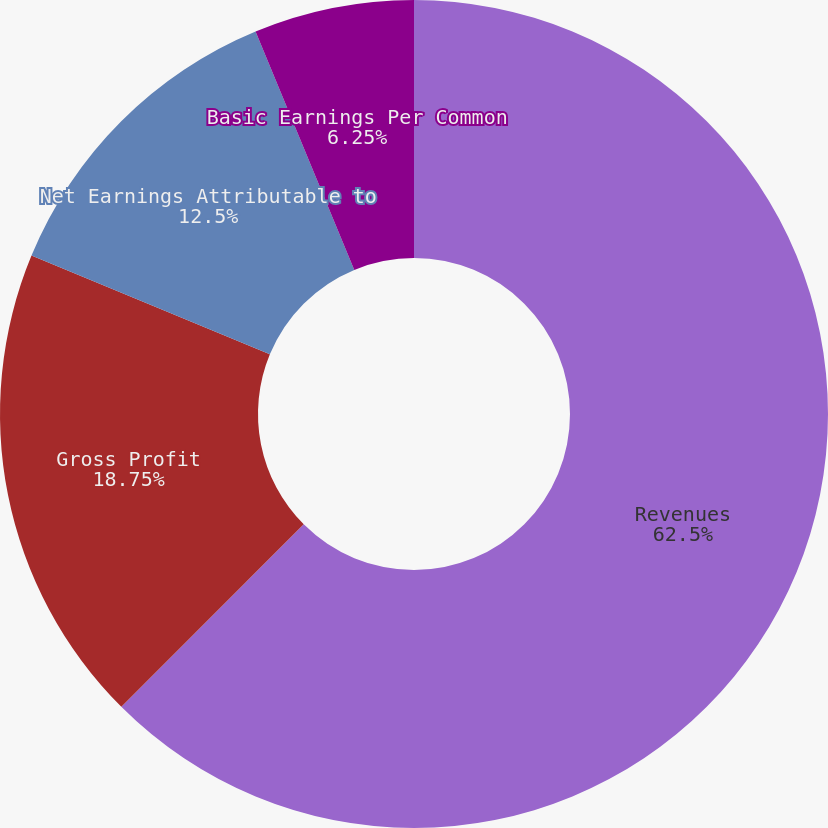Convert chart to OTSL. <chart><loc_0><loc_0><loc_500><loc_500><pie_chart><fcel>Revenues<fcel>Gross Profit<fcel>Net Earnings Attributable to<fcel>Basic Earnings Per Common<fcel>Diluted Earnings Per Common<nl><fcel>62.49%<fcel>18.75%<fcel>12.5%<fcel>6.25%<fcel>0.0%<nl></chart> 